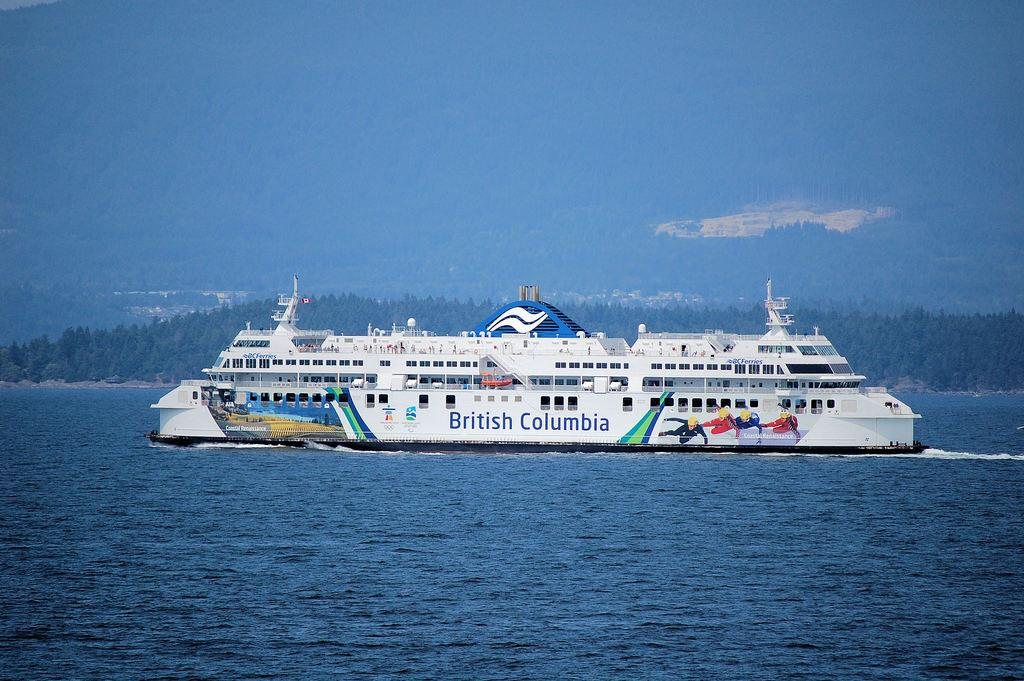Provide a one-sentence caption for the provided image. A white cruise ship that is advertising British Columbia on the side. 